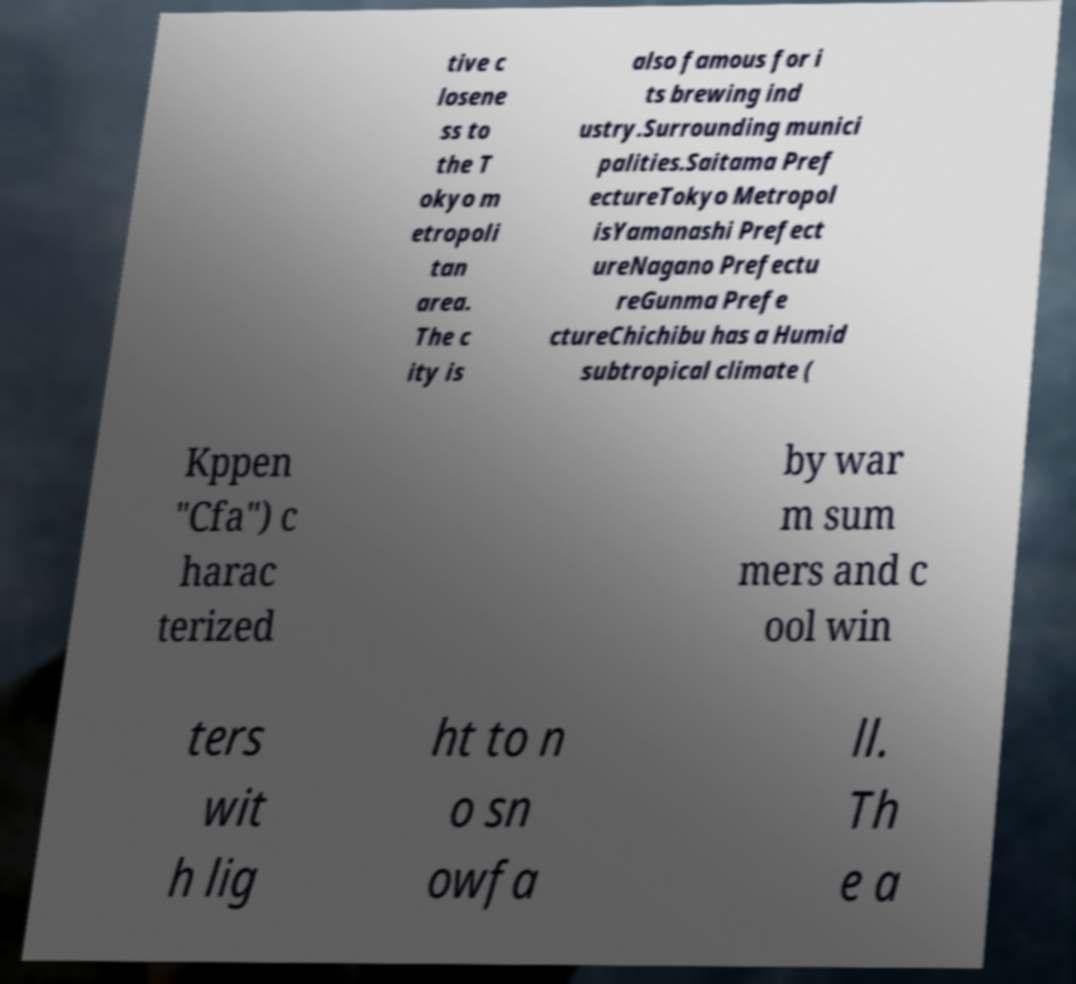Can you accurately transcribe the text from the provided image for me? tive c losene ss to the T okyo m etropoli tan area. The c ity is also famous for i ts brewing ind ustry.Surrounding munici palities.Saitama Pref ectureTokyo Metropol isYamanashi Prefect ureNagano Prefectu reGunma Prefe ctureChichibu has a Humid subtropical climate ( Kppen "Cfa") c harac terized by war m sum mers and c ool win ters wit h lig ht to n o sn owfa ll. Th e a 